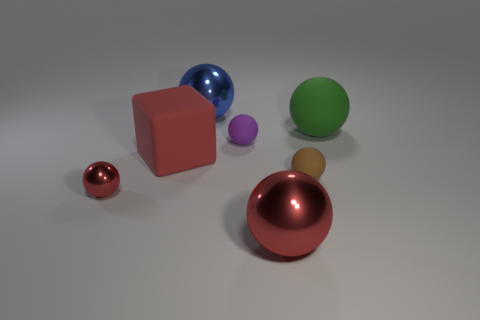How does the lighting affect the appearance of the objects in this scene? The lighting in the scene creates soft shadows and highlights that give the objects a three-dimensional appearance. The reflections are particularly noticeable on the metallic surfaces of the red and blue balls, enhancing their shiny textures, while the matte surfaces of the blocks and the green ball absorb more light, making them appear flatter by comparison. 